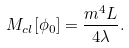<formula> <loc_0><loc_0><loc_500><loc_500>M _ { c l } [ \phi _ { 0 } ] = \frac { m ^ { 4 } L } { 4 \lambda } .</formula> 